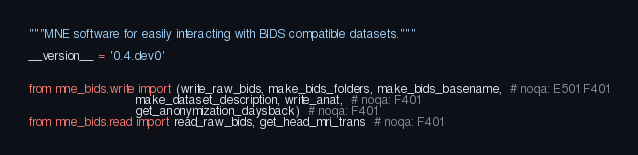Convert code to text. <code><loc_0><loc_0><loc_500><loc_500><_Python_>"""MNE software for easily interacting with BIDS compatible datasets."""

__version__ = '0.4.dev0'


from mne_bids.write import (write_raw_bids, make_bids_folders, make_bids_basename,  # noqa: E501 F401
                            make_dataset_description, write_anat,  # noqa: F401
                            get_anonymization_daysback)  # noqa: F401
from mne_bids.read import read_raw_bids, get_head_mri_trans  # noqa: F401
</code> 